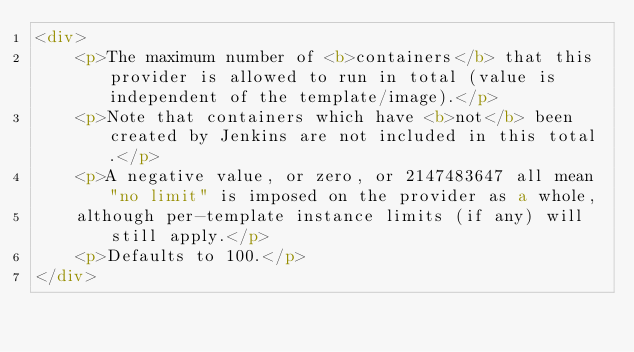Convert code to text. <code><loc_0><loc_0><loc_500><loc_500><_HTML_><div>
    <p>The maximum number of <b>containers</b> that this provider is allowed to run in total (value is independent of the template/image).</p>
    <p>Note that containers which have <b>not</b> been created by Jenkins are not included in this total.</p>
    <p>A negative value, or zero, or 2147483647 all mean "no limit" is imposed on the provider as a whole,
    although per-template instance limits (if any) will still apply.</p>
    <p>Defaults to 100.</p>
</div>
</code> 